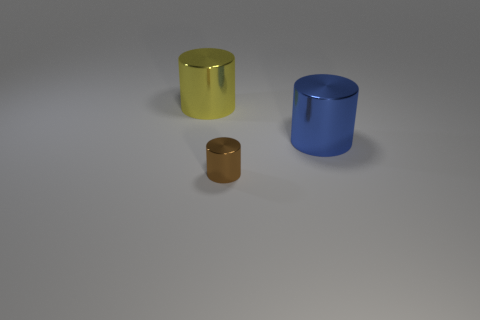What number of metallic things are either brown objects or big blue cylinders?
Provide a short and direct response. 2. Is there anything else that is the same size as the brown shiny cylinder?
Offer a terse response. No. What shape is the large metal thing that is in front of the big metallic object left of the big blue object?
Your answer should be very brief. Cylinder. Does the thing that is behind the large blue thing have the same material as the large thing that is to the right of the large yellow shiny object?
Offer a very short reply. Yes. How many shiny cylinders are left of the large cylinder in front of the big yellow thing?
Your response must be concise. 2. Is the shape of the large metal object right of the yellow metallic cylinder the same as the large shiny thing that is to the left of the brown cylinder?
Provide a succinct answer. Yes. How big is the shiny object that is in front of the big yellow metallic object and behind the brown shiny thing?
Keep it short and to the point. Large. What is the color of the other large thing that is the same shape as the blue object?
Give a very brief answer. Yellow. The shiny cylinder that is left of the thing that is in front of the blue shiny object is what color?
Ensure brevity in your answer.  Yellow. What is the shape of the big blue metal object?
Offer a very short reply. Cylinder. 